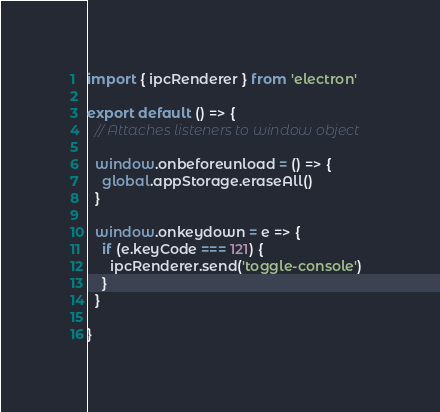<code> <loc_0><loc_0><loc_500><loc_500><_JavaScript_>import { ipcRenderer } from 'electron'

export default () => {
  // Attaches listeners to window object

  window.onbeforeunload = () => {
    global.appStorage.eraseAll()
  }

  window.onkeydown = e => {
    if (e.keyCode === 121) {
      ipcRenderer.send('toggle-console')
    }
  }

}
</code> 